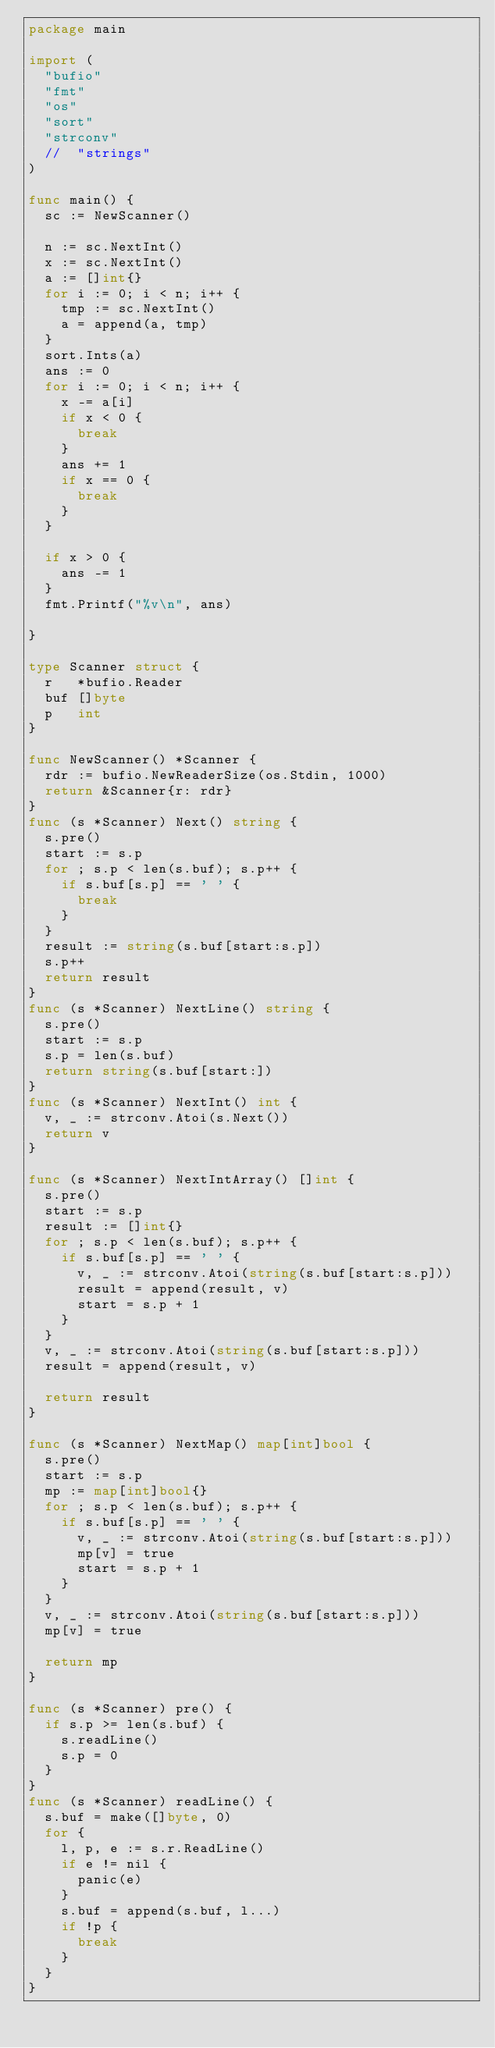Convert code to text. <code><loc_0><loc_0><loc_500><loc_500><_Go_>package main

import (
	"bufio"
	"fmt"
	"os"
	"sort"
	"strconv"
	//	"strings"
)

func main() {
	sc := NewScanner()

	n := sc.NextInt()
	x := sc.NextInt()
	a := []int{}
	for i := 0; i < n; i++ {
		tmp := sc.NextInt()
		a = append(a, tmp)
	}
	sort.Ints(a)
	ans := 0
	for i := 0; i < n; i++ {
		x -= a[i]
		if x < 0 {
			break
		}
		ans += 1
		if x == 0 {
			break
		}
	}

	if x > 0 {
		ans -= 1
	}
	fmt.Printf("%v\n", ans)

}

type Scanner struct {
	r   *bufio.Reader
	buf []byte
	p   int
}

func NewScanner() *Scanner {
	rdr := bufio.NewReaderSize(os.Stdin, 1000)
	return &Scanner{r: rdr}
}
func (s *Scanner) Next() string {
	s.pre()
	start := s.p
	for ; s.p < len(s.buf); s.p++ {
		if s.buf[s.p] == ' ' {
			break
		}
	}
	result := string(s.buf[start:s.p])
	s.p++
	return result
}
func (s *Scanner) NextLine() string {
	s.pre()
	start := s.p
	s.p = len(s.buf)
	return string(s.buf[start:])
}
func (s *Scanner) NextInt() int {
	v, _ := strconv.Atoi(s.Next())
	return v
}

func (s *Scanner) NextIntArray() []int {
	s.pre()
	start := s.p
	result := []int{}
	for ; s.p < len(s.buf); s.p++ {
		if s.buf[s.p] == ' ' {
			v, _ := strconv.Atoi(string(s.buf[start:s.p]))
			result = append(result, v)
			start = s.p + 1
		}
	}
	v, _ := strconv.Atoi(string(s.buf[start:s.p]))
	result = append(result, v)

	return result
}

func (s *Scanner) NextMap() map[int]bool {
	s.pre()
	start := s.p
	mp := map[int]bool{}
	for ; s.p < len(s.buf); s.p++ {
		if s.buf[s.p] == ' ' {
			v, _ := strconv.Atoi(string(s.buf[start:s.p]))
			mp[v] = true
			start = s.p + 1
		}
	}
	v, _ := strconv.Atoi(string(s.buf[start:s.p]))
	mp[v] = true

	return mp
}

func (s *Scanner) pre() {
	if s.p >= len(s.buf) {
		s.readLine()
		s.p = 0
	}
}
func (s *Scanner) readLine() {
	s.buf = make([]byte, 0)
	for {
		l, p, e := s.r.ReadLine()
		if e != nil {
			panic(e)
		}
		s.buf = append(s.buf, l...)
		if !p {
			break
		}
	}
}
</code> 